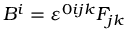<formula> <loc_0><loc_0><loc_500><loc_500>B ^ { i } = \varepsilon ^ { 0 i j k } F _ { j k }</formula> 